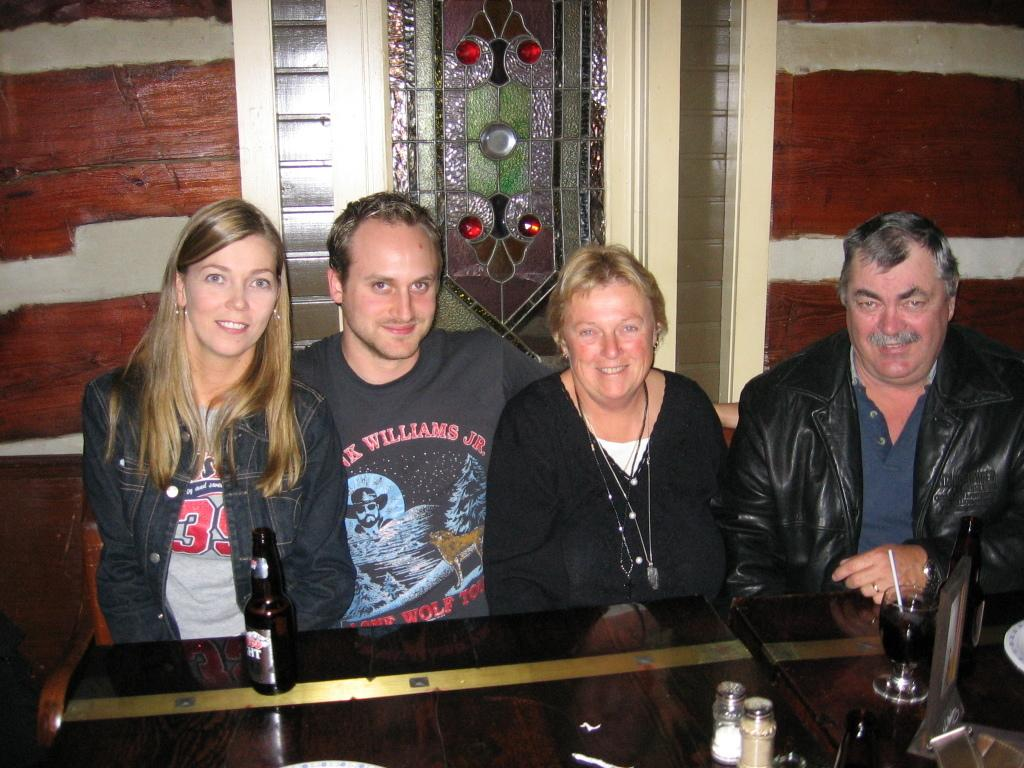How many people are present in the image? There are four people in the image. What are the people doing in the image? The people are sitting in front of a table. What expressions do the people have in the image? The people have smiles on their faces. What can be seen on the table in the image? There is a bottle, a glass of drink with a straw, and other objects on the table. What type of collar can be seen on the people in the image? There are no collars visible on the people in the image. What kind of test is being conducted in the image? There is no test being conducted in the image; it features four people sitting at a table with smiles on their faces. 